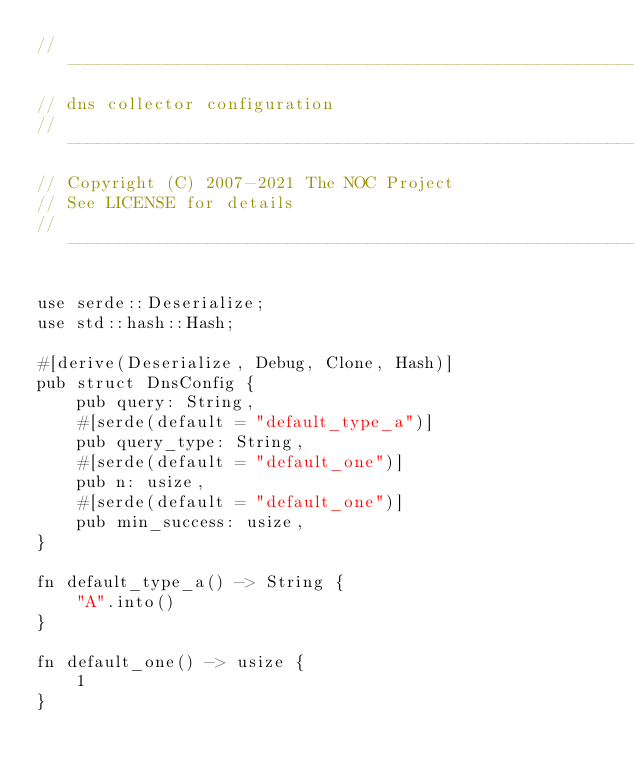<code> <loc_0><loc_0><loc_500><loc_500><_Rust_>// ---------------------------------------------------------------------
// dns collector configuration
// ---------------------------------------------------------------------
// Copyright (C) 2007-2021 The NOC Project
// See LICENSE for details
// ---------------------------------------------------------------------

use serde::Deserialize;
use std::hash::Hash;

#[derive(Deserialize, Debug, Clone, Hash)]
pub struct DnsConfig {
    pub query: String,
    #[serde(default = "default_type_a")]
    pub query_type: String,
    #[serde(default = "default_one")]
    pub n: usize,
    #[serde(default = "default_one")]
    pub min_success: usize,
}

fn default_type_a() -> String {
    "A".into()
}

fn default_one() -> usize {
    1
}
</code> 